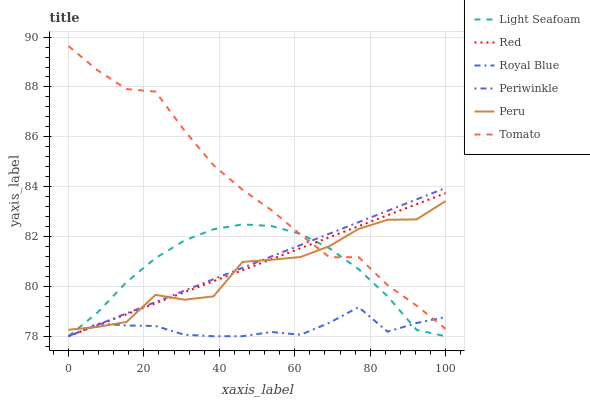Does Royal Blue have the minimum area under the curve?
Answer yes or no. Yes. Does Tomato have the maximum area under the curve?
Answer yes or no. Yes. Does Periwinkle have the minimum area under the curve?
Answer yes or no. No. Does Periwinkle have the maximum area under the curve?
Answer yes or no. No. Is Periwinkle the smoothest?
Answer yes or no. Yes. Is Peru the roughest?
Answer yes or no. Yes. Is Royal Blue the smoothest?
Answer yes or no. No. Is Royal Blue the roughest?
Answer yes or no. No. Does Royal Blue have the lowest value?
Answer yes or no. Yes. Does Peru have the lowest value?
Answer yes or no. No. Does Tomato have the highest value?
Answer yes or no. Yes. Does Periwinkle have the highest value?
Answer yes or no. No. Does Tomato intersect Light Seafoam?
Answer yes or no. Yes. Is Tomato less than Light Seafoam?
Answer yes or no. No. Is Tomato greater than Light Seafoam?
Answer yes or no. No. 